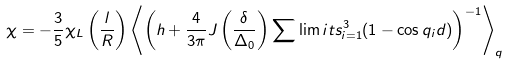Convert formula to latex. <formula><loc_0><loc_0><loc_500><loc_500>\chi = - \frac { 3 } { 5 } \chi _ { L } \left ( \frac { l } { R } \right ) \left \langle \left ( h + \frac { 4 } { 3 \pi } J \left ( \frac { \delta } { \Delta _ { 0 } } \right ) \sum \lim i t s _ { i = 1 } ^ { 3 } ( 1 - \cos q _ { i } d ) \right ) ^ { - 1 } \right \rangle _ { q }</formula> 